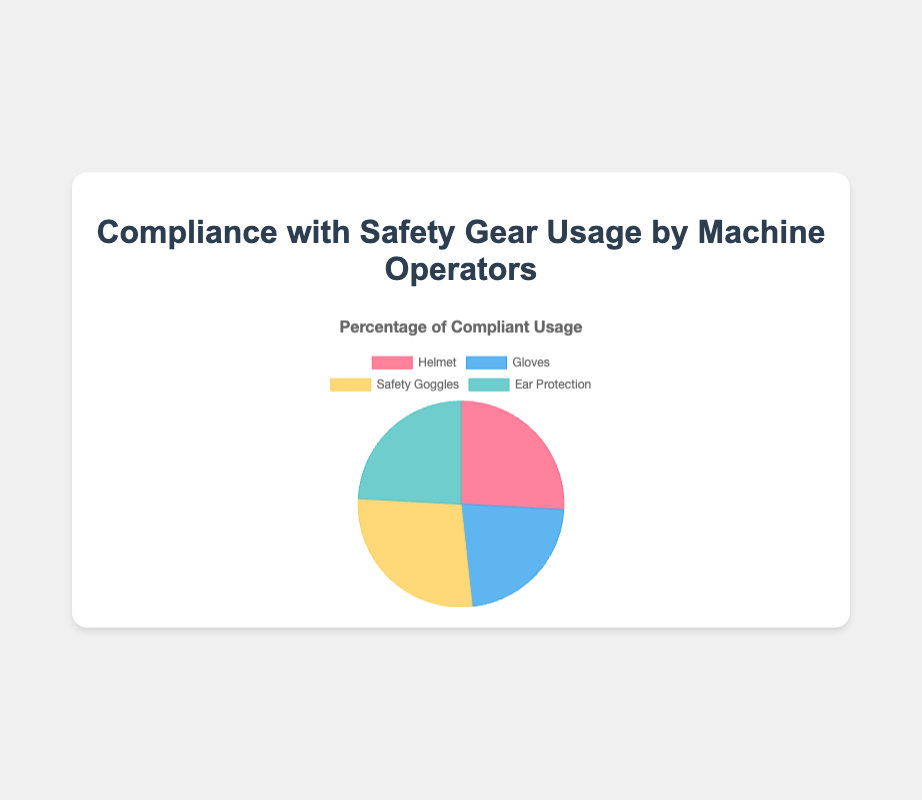Which safety gear showed the highest compliance rate? The pie chart displays the compliance rates for Helmet, Gloves, Safety Goggles, and Ear Protection. The highest compliance rate is associated with Safety Goggles at 80%.
Answer: Safety Goggles Which safety gear has the lowest compliance rate? By comparing the compliance percentages for each gear (Helmet: 75%, Gloves: 65%, Safety Goggles: 80%, Ear Protection: 70%), Gloves has the lowest compliance rate at 65%.
Answer: Gloves What is the total compliance rate for Helmet and Gloves usage combined? The compliance rates for Helmet and Gloves are given as 75% and 65% respectively. Summing these gives 75% + 65% = 140%.
Answer: 140% Is the compliance rate for Ear Protection higher than that for Helmets? The compliance rate for Ear Protection is 70%, while for Helmets it is 75%. Since 70% is less than 75%, Ear Protection has a lower compliance rate than Helmets.
Answer: No What is the difference in compliance rates between Safety Goggles and Gloves? The compliance rate for Safety Goggles is 80%, and for Gloves, it is 65%. The difference is 80% - 65% = 15%.
Answer: 15% Which safety gear uses red in its visual representation? The pie chart segments each piece of safety gear with different colors: Helmet, Gloves, Safety Goggles, and Ear Protection. The segment for Helmet is colored red.
Answer: Helmet What is the average compliance rate for all four safety gear types? The compliance rates are 75% (Helmet), 65% (Gloves), 80% (Safety Goggles), and 70% (Ear Protection). The average is calculated as (75% + 65% + 80% + 70%) / 4 = 290% / 4 = 72.5%.
Answer: 72.5% Which two safety gears combined have the highest total compliance rate? Adding the compliance rates of each possible pair: Helmet and Gloves (75% + 65% = 140%), Helmet and Safety Goggles (75% + 80% = 155%), Helmet and Ear Protection (75% + 70% = 145%), Gloves and Safety Goggles (65% + 80% = 145%), Gloves and Ear Protection (65% + 70% = 135%), Safety Goggles and Ear Protection (80% + 70% = 150%). Helmet and Safety Goggles combined have the highest total compliance rate of 155%.
Answer: Helmet and Safety Goggles Is the compliance rate for Safety Goggles equal to the sum of Partial Compliance rates for all types of gear? The Safety Goggles compliance rate is 80%. Summing the Partial Compliance rates: Helmet (10%), Gloves (15%), Safety Goggles (10%), Ear Protection (10%) gives 10% + 15% + 10% + 10% = 45%. 80% is not equal to 45%.
Answer: No 